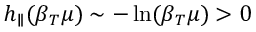Convert formula to latex. <formula><loc_0><loc_0><loc_500><loc_500>h _ { \| } ( \beta _ { T } \mu ) \sim - \ln ( \beta _ { T } \mu ) > 0</formula> 